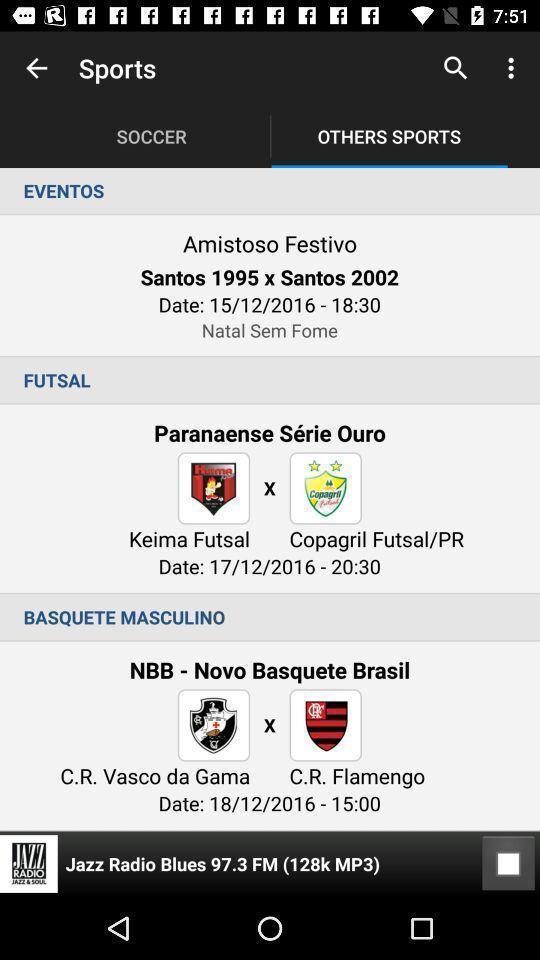Summarize the main components in this picture. Screen shows events details. 